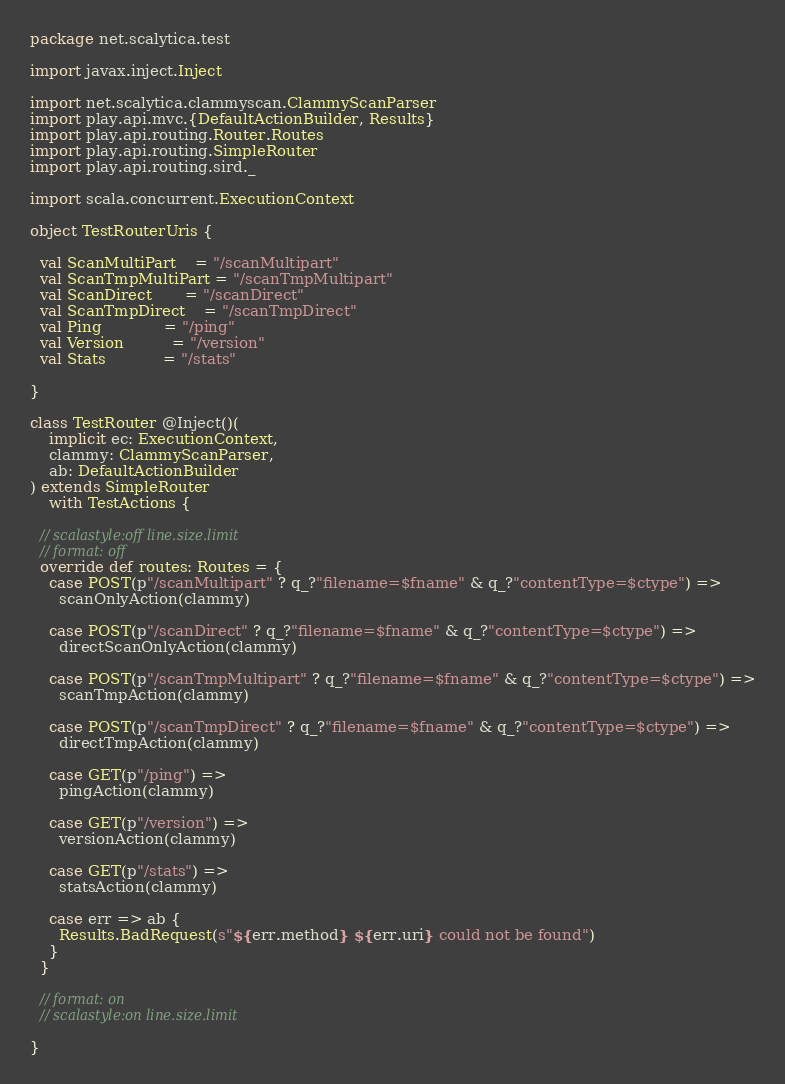Convert code to text. <code><loc_0><loc_0><loc_500><loc_500><_Scala_>package net.scalytica.test

import javax.inject.Inject

import net.scalytica.clammyscan.ClammyScanParser
import play.api.mvc.{DefaultActionBuilder, Results}
import play.api.routing.Router.Routes
import play.api.routing.SimpleRouter
import play.api.routing.sird._

import scala.concurrent.ExecutionContext

object TestRouterUris {

  val ScanMultiPart    = "/scanMultipart"
  val ScanTmpMultiPart = "/scanTmpMultipart"
  val ScanDirect       = "/scanDirect"
  val ScanTmpDirect    = "/scanTmpDirect"
  val Ping             = "/ping"
  val Version          = "/version"
  val Stats            = "/stats"

}

class TestRouter @Inject()(
    implicit ec: ExecutionContext,
    clammy: ClammyScanParser,
    ab: DefaultActionBuilder
) extends SimpleRouter
    with TestActions {

  // scalastyle:off line.size.limit
  // format: off
  override def routes: Routes = {
    case POST(p"/scanMultipart" ? q_?"filename=$fname" & q_?"contentType=$ctype") =>
      scanOnlyAction(clammy)

    case POST(p"/scanDirect" ? q_?"filename=$fname" & q_?"contentType=$ctype") =>
      directScanOnlyAction(clammy)

    case POST(p"/scanTmpMultipart" ? q_?"filename=$fname" & q_?"contentType=$ctype") =>
      scanTmpAction(clammy)

    case POST(p"/scanTmpDirect" ? q_?"filename=$fname" & q_?"contentType=$ctype") =>
      directTmpAction(clammy)

    case GET(p"/ping") =>
      pingAction(clammy)

    case GET(p"/version") =>
      versionAction(clammy)

    case GET(p"/stats") =>
      statsAction(clammy)

    case err => ab {
      Results.BadRequest(s"${err.method} ${err.uri} could not be found")
    }
  }

  // format: on
  // scalastyle:on line.size.limit

}
</code> 